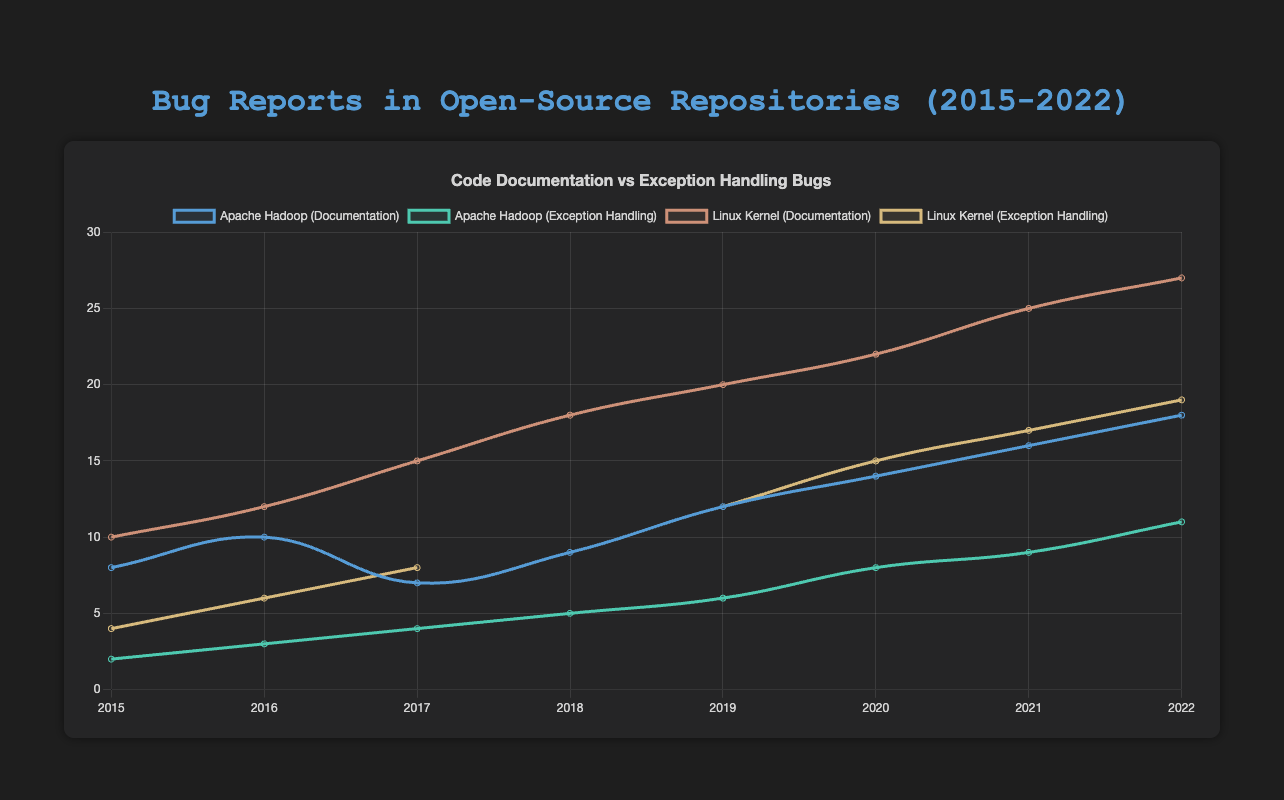Which repository had the highest number of code documentation bugs in 2022? Observe the highest point on the line representing code documentation bugs for 2022. Mozilla Firefox has the highest point on this line.
Answer: Mozilla Firefox How did the number of exception handling bugs for Apache Hadoop change from 2015 to 2022? Compare the points for Apache Hadoop (Exception Handling) in 2015 and 2022. In 2015, it had 2 bugs, and in 2022, it had 11. There's an increase of 9 bugs.
Answer: Increased by 9 Which repository showed a greater increase in code documentation bugs from 2015 to 2022, Apache Hadoop or MySQL? Calculate the difference in code documentation bugs from 2015 to 2022 for both repositories. Apache Hadoop: 18 - 8 = 10, MySQL: 20 - 6 = 14. So, MySQL had a greater increase.
Answer: MySQL What is the average number of exception handling bugs for the Linux Kernel from 2015 to 2022? Sum the number of exception handling bugs for the Linux Kernel over the years and divide by the number of years. Sum: 4 + 6 + 8 + 10 + 12 + 15 + 17 + 19 = 91, Number of years: 8. Average: 91 / 8 = 11.375
Answer: 11.375 Which repository had the smallest increase in exception handling bugs from 2015 to 2022? Calculate the difference in exception handling bugs from 2015 to 2022 for each repository. Apache Hadoop: 11 - 2 = 9, Linux Kernel: 19 - 4 = 15, MySQL: 8 - 1 = 7, PostgreSQL: 11 - 3 = 8, Mozilla Firefox: 18 - 5 = 13. MySQL had the smallest increase.
Answer: MySQL Which repository has the steadiest increase in code documentation bugs over the years? Examine the slope of the lines representing code documentation bugs for each repository. The one with the most consistent slope indicates steadiness. Postgresql seems to have a steady increase over the years.
Answer: PostgreSQL In which year did Mozilla Firefox see a noticeable rise in code documentation bugs compared to the previous year? Identify the year where there's a sharp rise in the line for Mozilla Firefox code documentation bugs. There's a noticeable rise from 2017 (20) to 2018 (21).
Answer: 2018 Which repository had comparable numbers of code documentation bugs and exception handling bugs in 2020? Compare the y-values of code documentation and exception handling bugs for all repositories in 2020. For Apache Hadoop, documentation bugs = 14, exception handling bugs = 8. For Linux Kernel, documentation bugs = 22, exception handling bugs = 15. For MySQL, documentation bugs = 15, exception handling bugs = 6. For PostgreSQL, documentation bugs = 12, exception handling bugs = 8. For Mozilla Firefox, documentation bugs = 25, exception handling bugs = 14. The closest values are for Apache Hadoop and PostgreSQL.
Answer: PostgreSQL What is the total number of exception handling bugs reported for PostgreSQL from 2015 to 2022? Sum the number of exception handling bugs for PostgreSQL over the years: 3 + 4 + 5 + 6 + 7 + 8 + 10 + 11 = 54
Answer: 54 